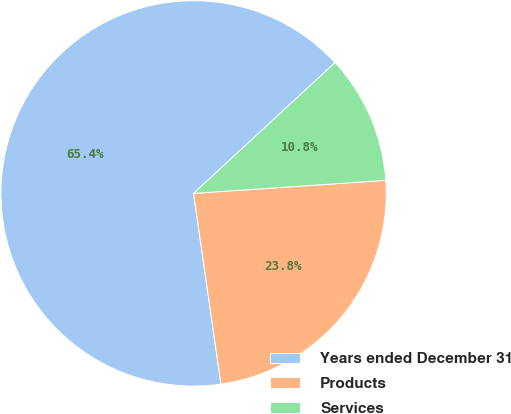<chart> <loc_0><loc_0><loc_500><loc_500><pie_chart><fcel>Years ended December 31<fcel>Products<fcel>Services<nl><fcel>65.39%<fcel>23.81%<fcel>10.8%<nl></chart> 